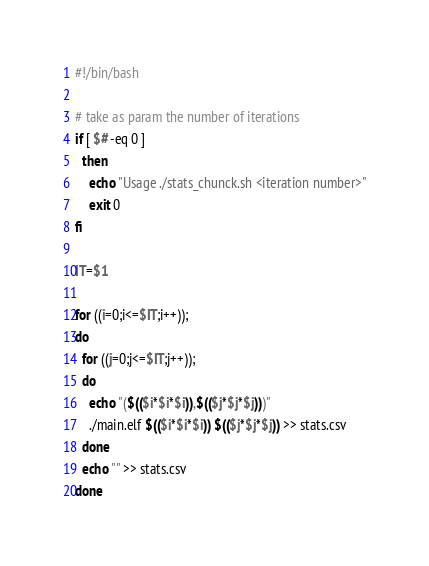Convert code to text. <code><loc_0><loc_0><loc_500><loc_500><_Bash_>#!/bin/bash

# take as param the number of iterations
if [ $# -eq 0 ]
  then
    echo "Usage ./stats_chunck.sh <iteration number>"
    exit 0
fi

IT=$1

for ((i=0;i<=$IT;i++));
do
  for ((j=0;j<=$IT;j++));
  do
    echo "($(($i*$i*$i)),$(($j*$j*$j)))"
    ./main.elf $(($i*$i*$i)) $(($j*$j*$j)) >> stats.csv
  done
  echo "" >> stats.csv
done
</code> 